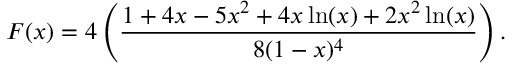Convert formula to latex. <formula><loc_0><loc_0><loc_500><loc_500>F ( x ) = 4 \left ( \frac { 1 + 4 x - 5 x ^ { 2 } + 4 x \ln ( x ) + 2 x ^ { 2 } \ln ( x ) } { 8 ( 1 - x ) ^ { 4 } } \right ) .</formula> 